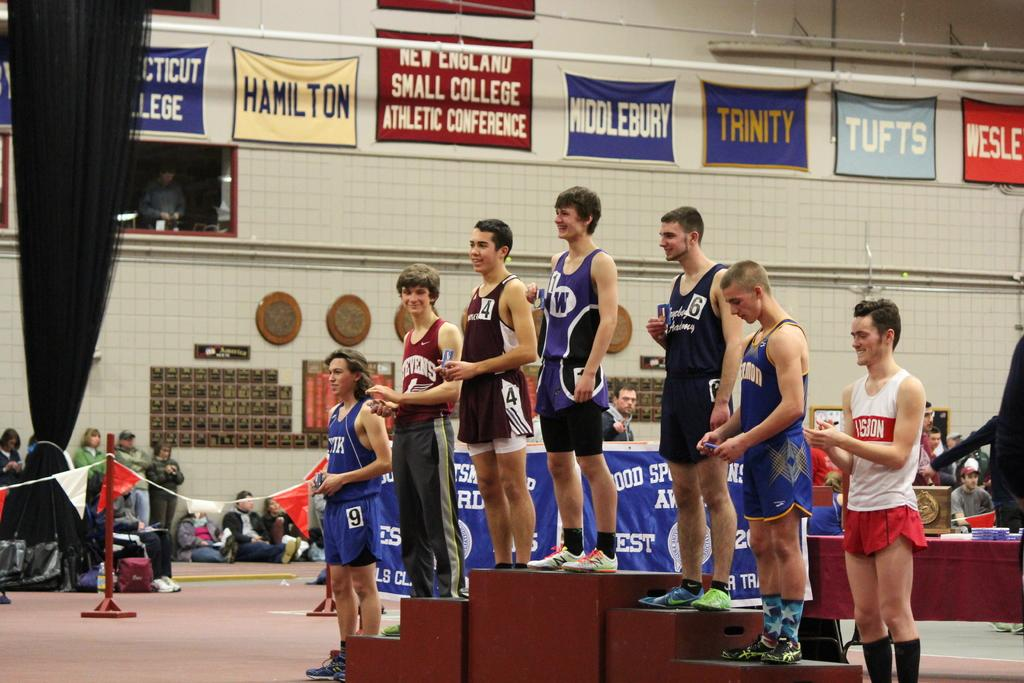<image>
Summarize the visual content of the image. Boys standing on a pedestal for a small college conference from a variety of schools including Hamilton, Middlebury, Trinity, and Tufts 